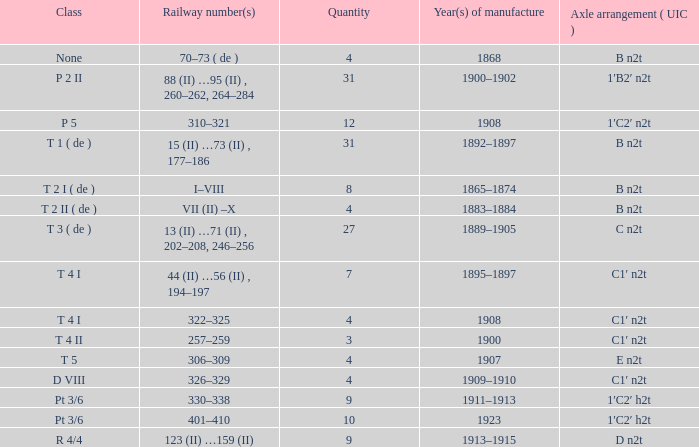What is the railway number of t 4 ii class? 257–259. 